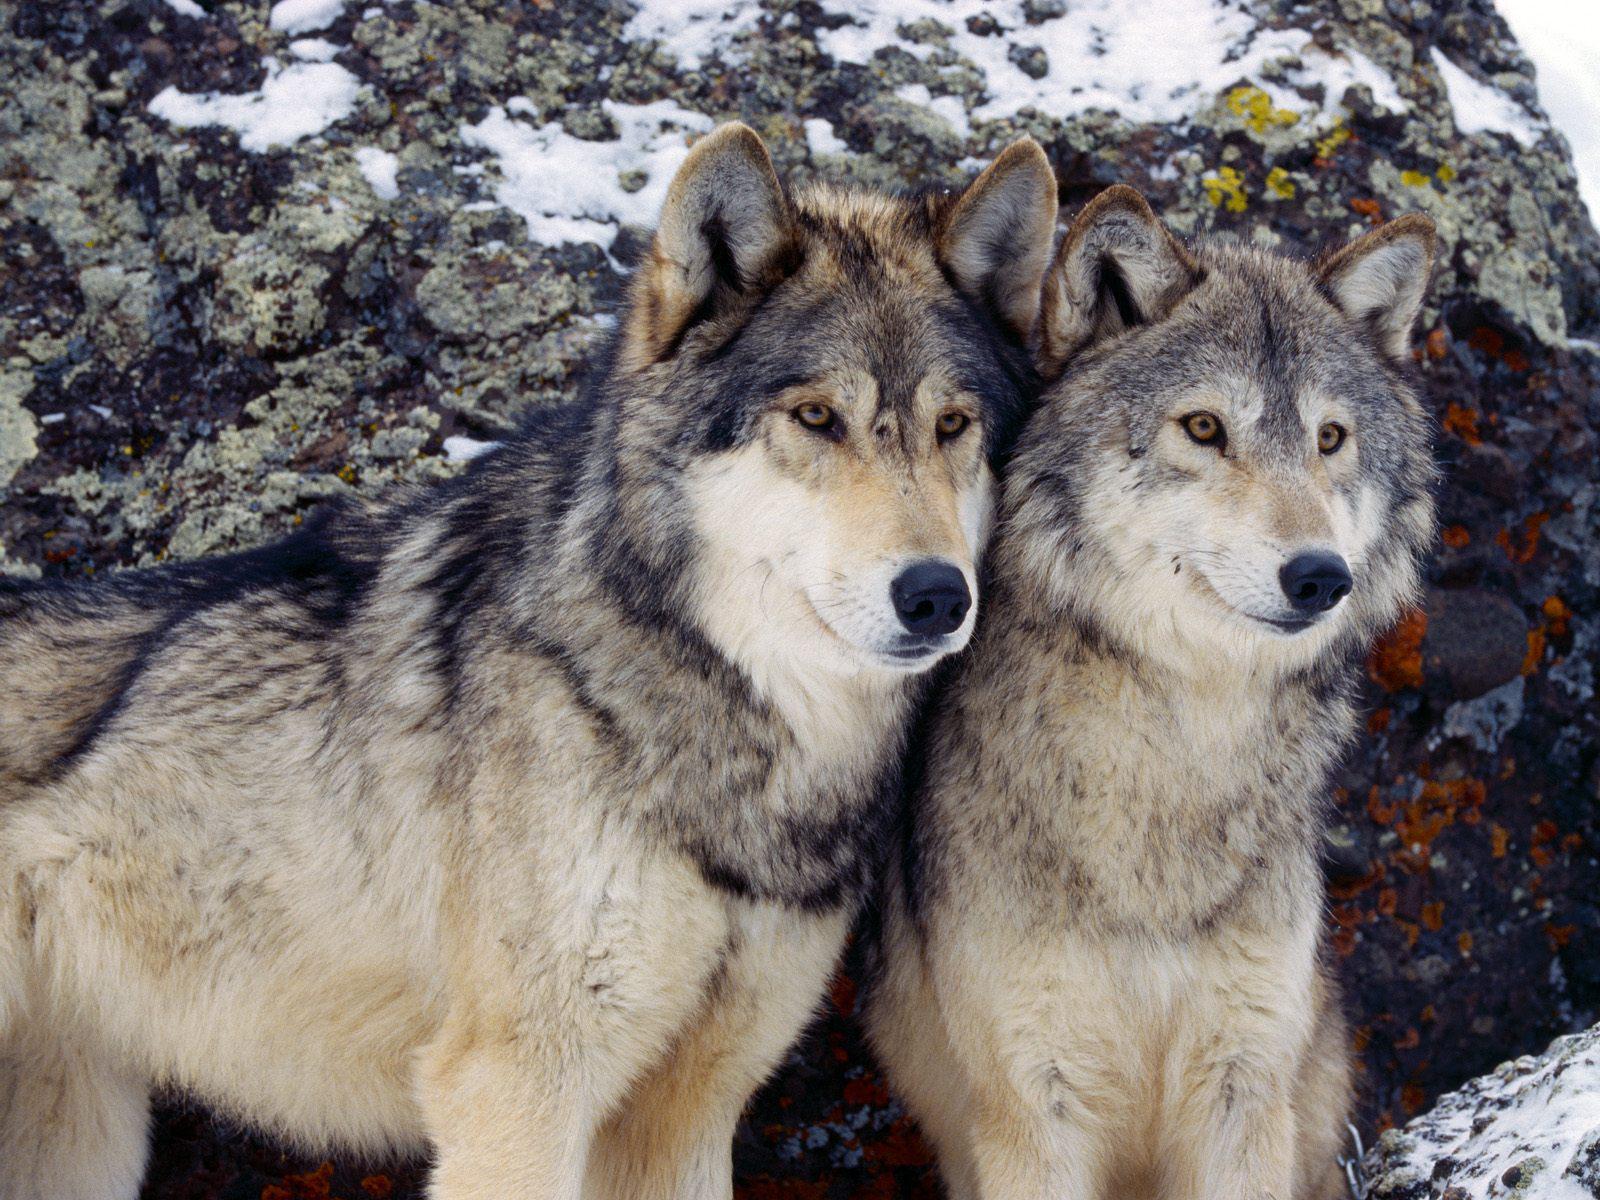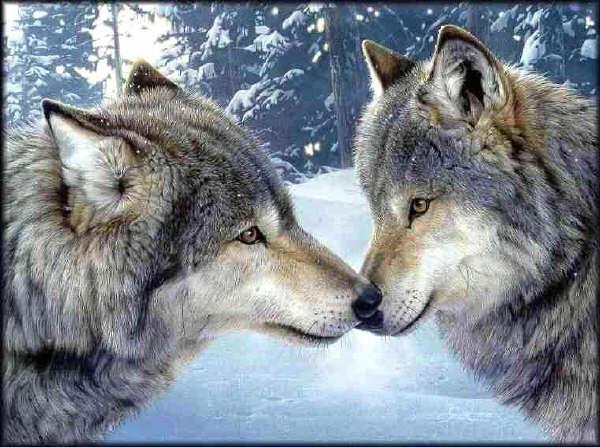The first image is the image on the left, the second image is the image on the right. Examine the images to the left and right. Is the description "At least one wolf is standing in front of trees with its head raised in a howling pose." accurate? Answer yes or no. No. The first image is the image on the left, the second image is the image on the right. For the images displayed, is the sentence "There is no more than one wolf in the right image." factually correct? Answer yes or no. No. 